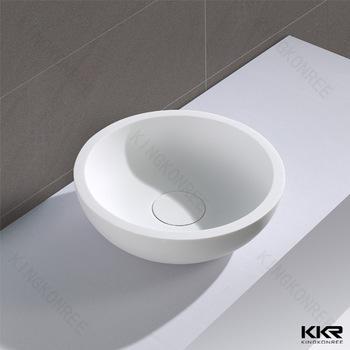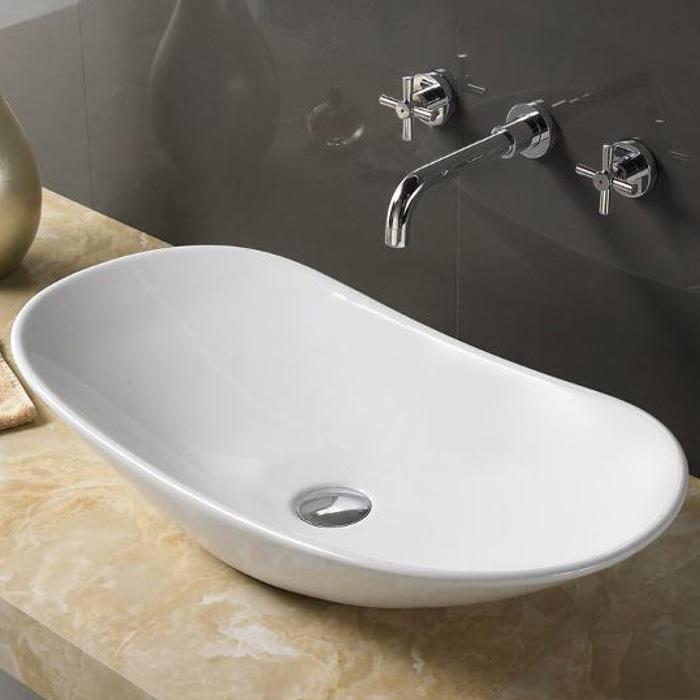The first image is the image on the left, the second image is the image on the right. Evaluate the accuracy of this statement regarding the images: "The sink on the right has a rectangular shape.". Is it true? Answer yes or no. No. 